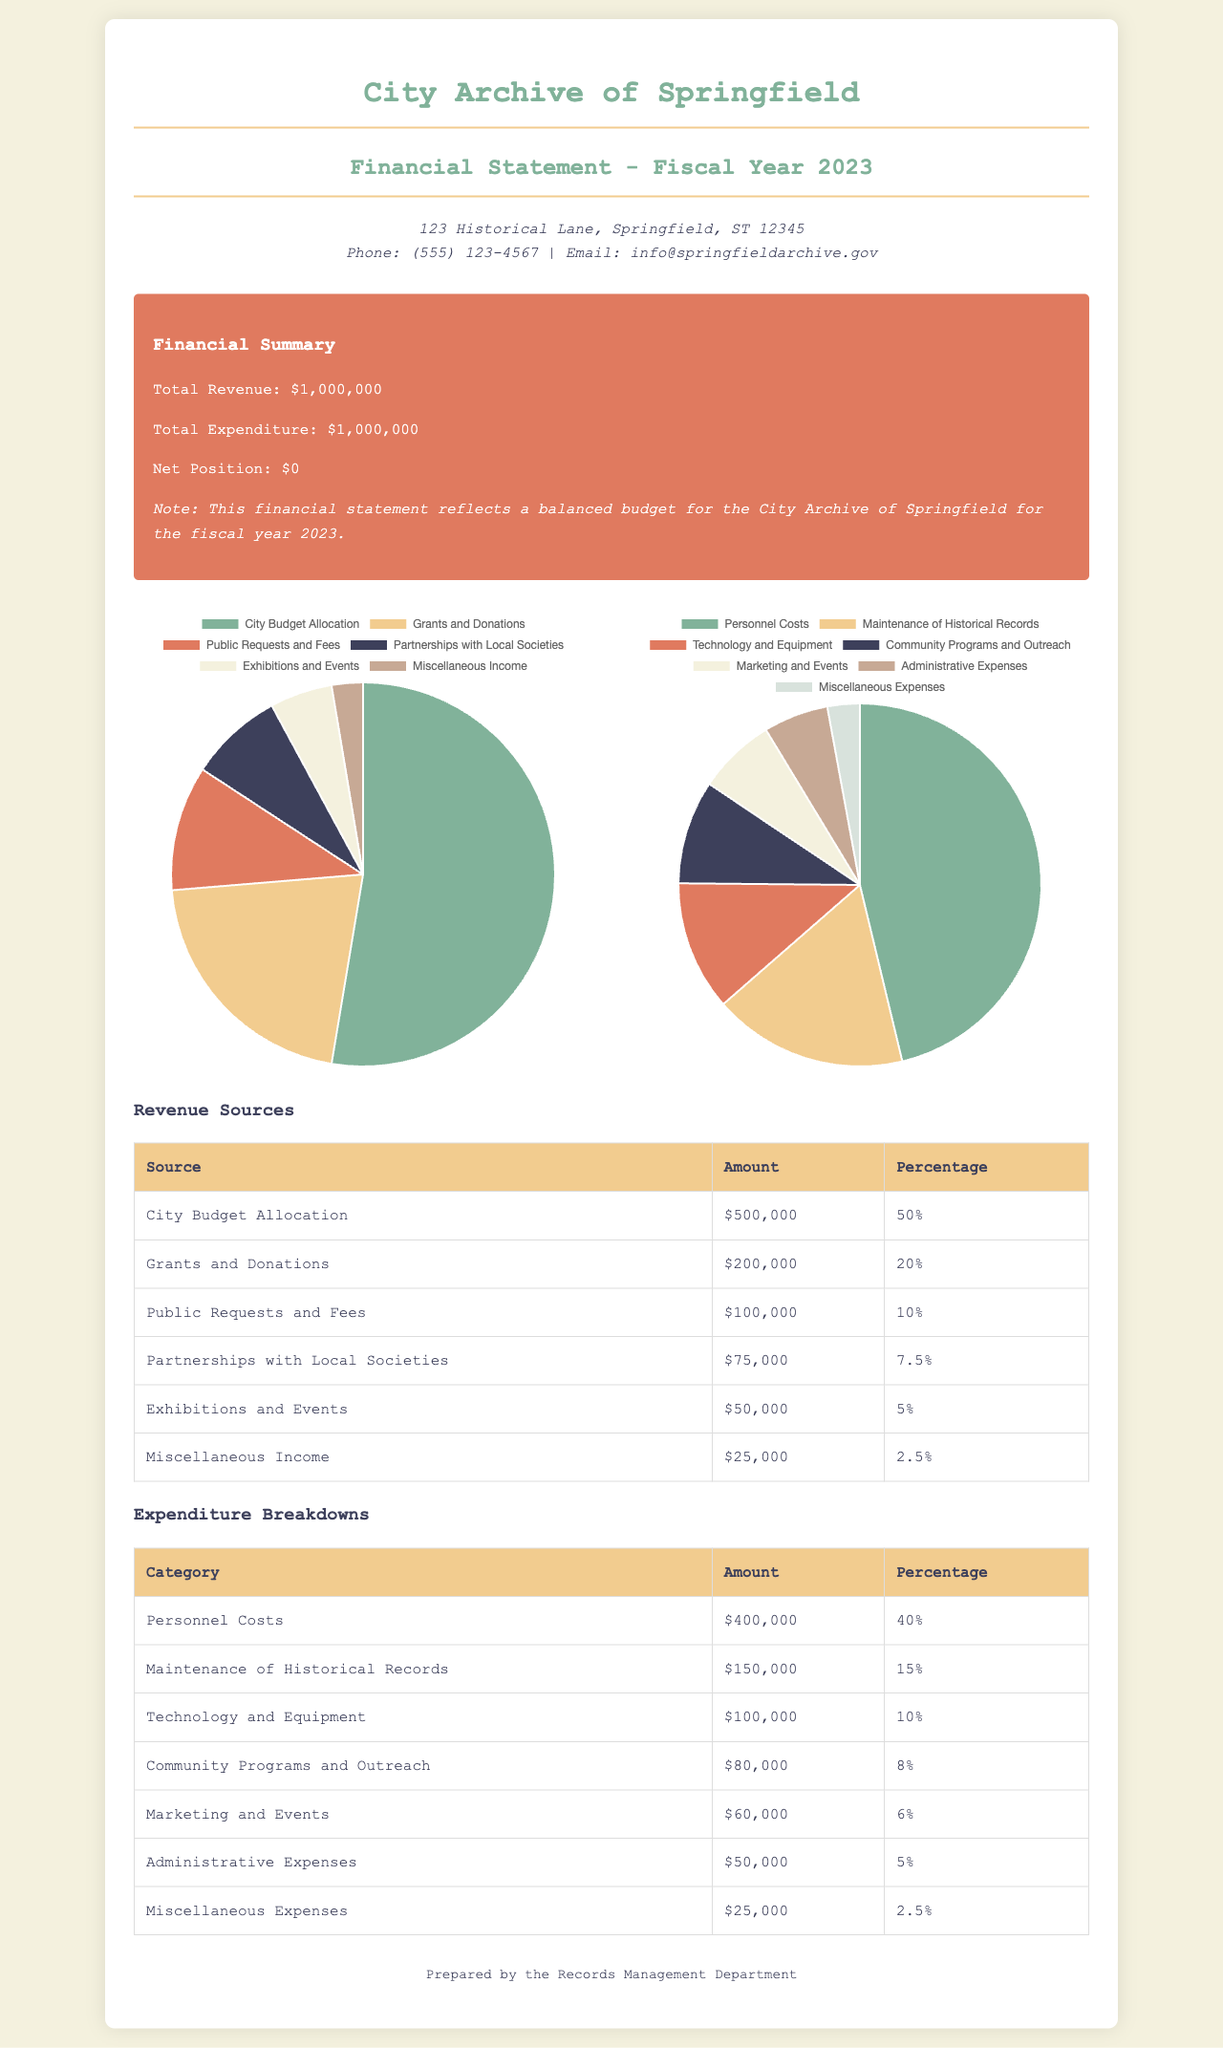What is the total revenue? The total revenue is stated in the financial summary section of the document.
Answer: $1,000,000 What is the net position for fiscal year 2023? The net position is mentioned in the financial summary and represents the difference between total revenue and total expenditure.
Answer: $0 What percentage of total revenue comes from city budget allocation? The percentage is provided in the revenue sources table and reflects the allocation from the city budget.
Answer: 50% What is the amount spent on personnel costs? The expenditure breakdown details the amount allocated to personnel costs as one of the main categories.
Answer: $400,000 How much revenue is generated from miscellaneous income? The revenue sources table includes this specific income category and its respective amount.
Answer: $25,000 Which category represents the highest expenditure? The breakdown of expenditures shows which category has the largest amount spent.
Answer: Personnel Costs What percentage does community programs and outreach represent in expenditures? The expenditures table specifies the percentage allocated for this category compared to the total expenditure.
Answer: 8% What are the total expenditures for fiscal year 2023? The financial summary directly states the total expenditures for the year.
Answer: $1,000,000 How many revenue sources are listed in the document? The revenue sources section of the document mentions the number of distinct sources included in the table.
Answer: 6 